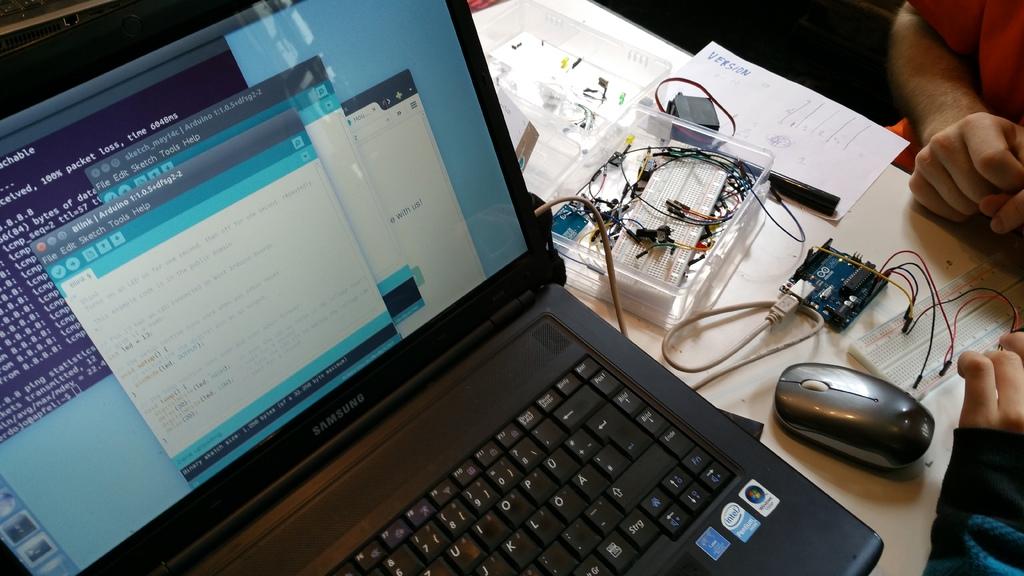What is the brand of the laptop?
Ensure brevity in your answer.  Samsung. 